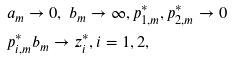Convert formula to latex. <formula><loc_0><loc_0><loc_500><loc_500>& a _ { m } \to 0 , \ b _ { m } \to \infty , p ^ { * } _ { 1 , m } , p _ { 2 , m } ^ { * } \to 0 \ \\ & p ^ { * } _ { i , m } b _ { m } \to z _ { i } ^ { * } , i = 1 , 2 ,</formula> 